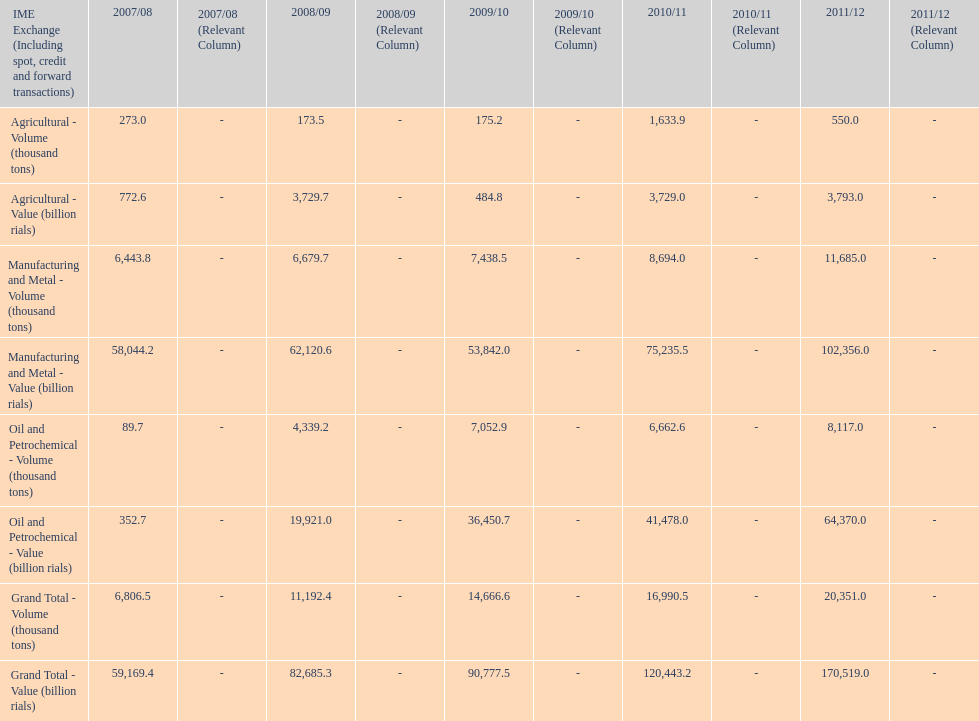Which year had the largest agricultural volume? 2010/11. 